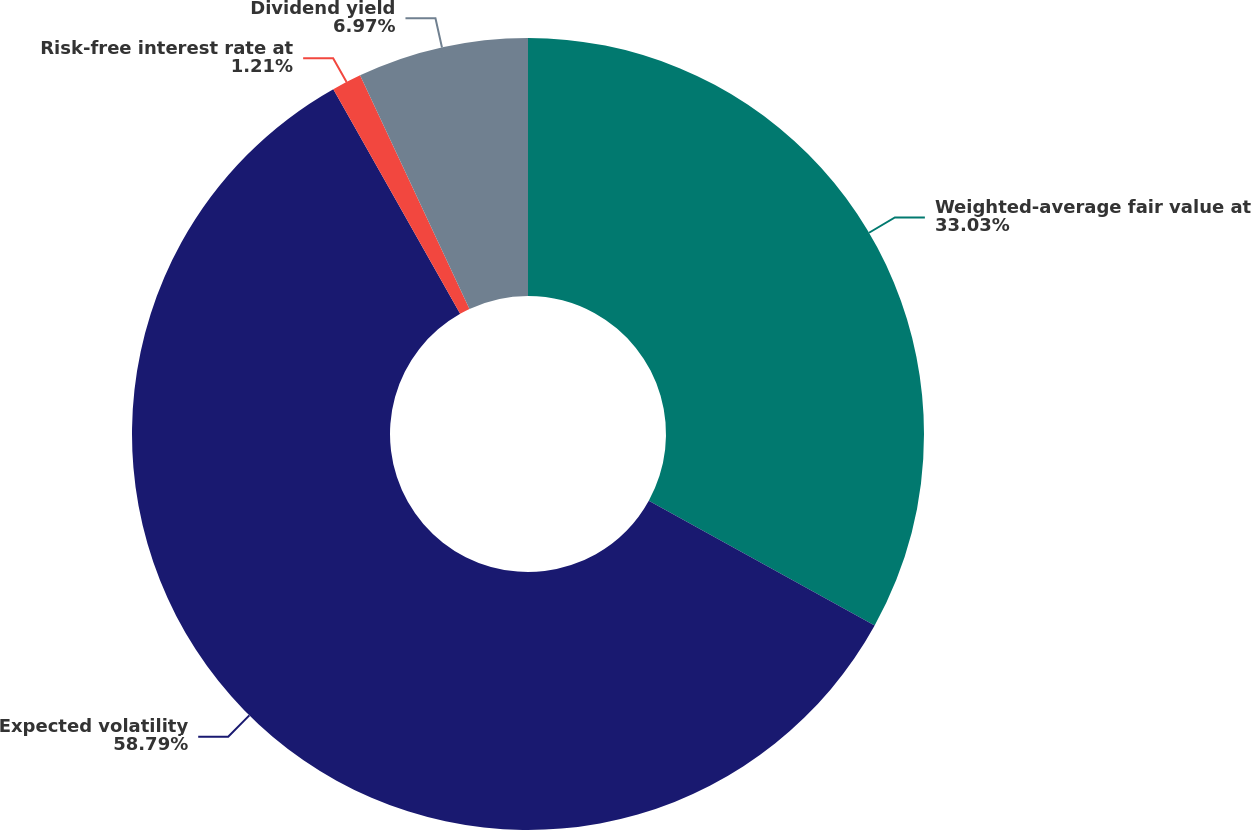Convert chart to OTSL. <chart><loc_0><loc_0><loc_500><loc_500><pie_chart><fcel>Weighted-average fair value at<fcel>Expected volatility<fcel>Risk-free interest rate at<fcel>Dividend yield<nl><fcel>33.03%<fcel>58.79%<fcel>1.21%<fcel>6.97%<nl></chart> 